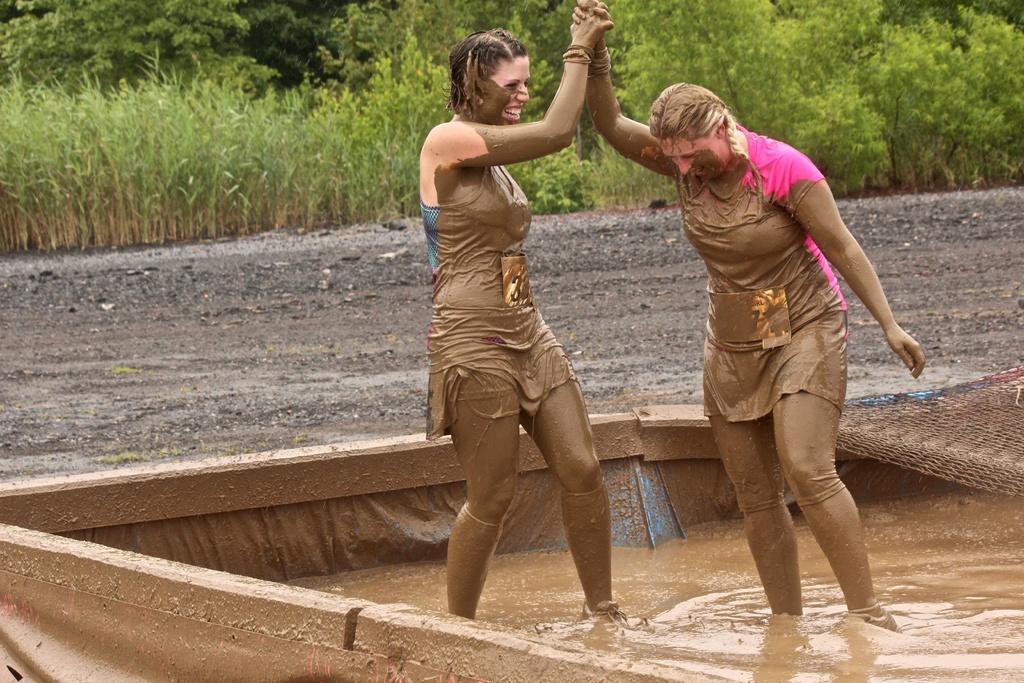In one or two sentences, can you explain what this image depicts? This picture shows couple of woman standing in the mud and they are holding hands and we see trees, plants and we see smile on their faces. 